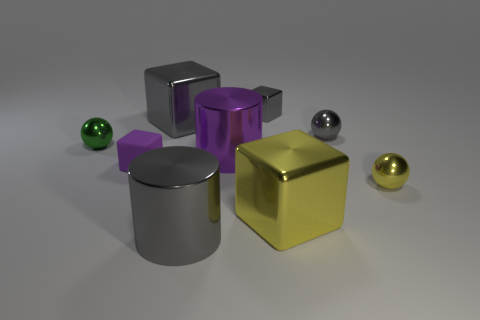Can you tell me what colors you see in the image and which object stands out the most? The image showcases objects in several colors: silver, purple, gold, and green. The gold cube stands out the most due to its bright, reflective surface and central position in the arrangement. What do you think the purpose of these objects might be? The objects appear to be simplistic and stylized, leading to the possibility that they are part of a visual composition or demonstration, perhaps to showcase the play of light on different surfaces or for use in a 3D modeling program or graphic design. 